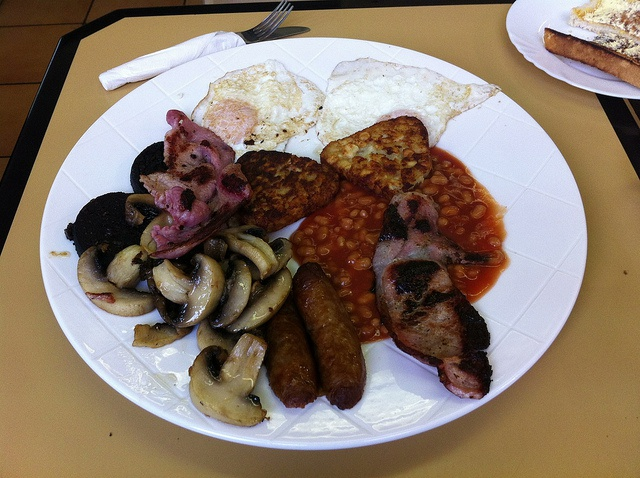Describe the objects in this image and their specific colors. I can see dining table in lavender, black, tan, olive, and maroon tones, sandwich in black, lightgray, brown, and tan tones, fork in black, gray, and darkgray tones, and knife in black and gray tones in this image. 